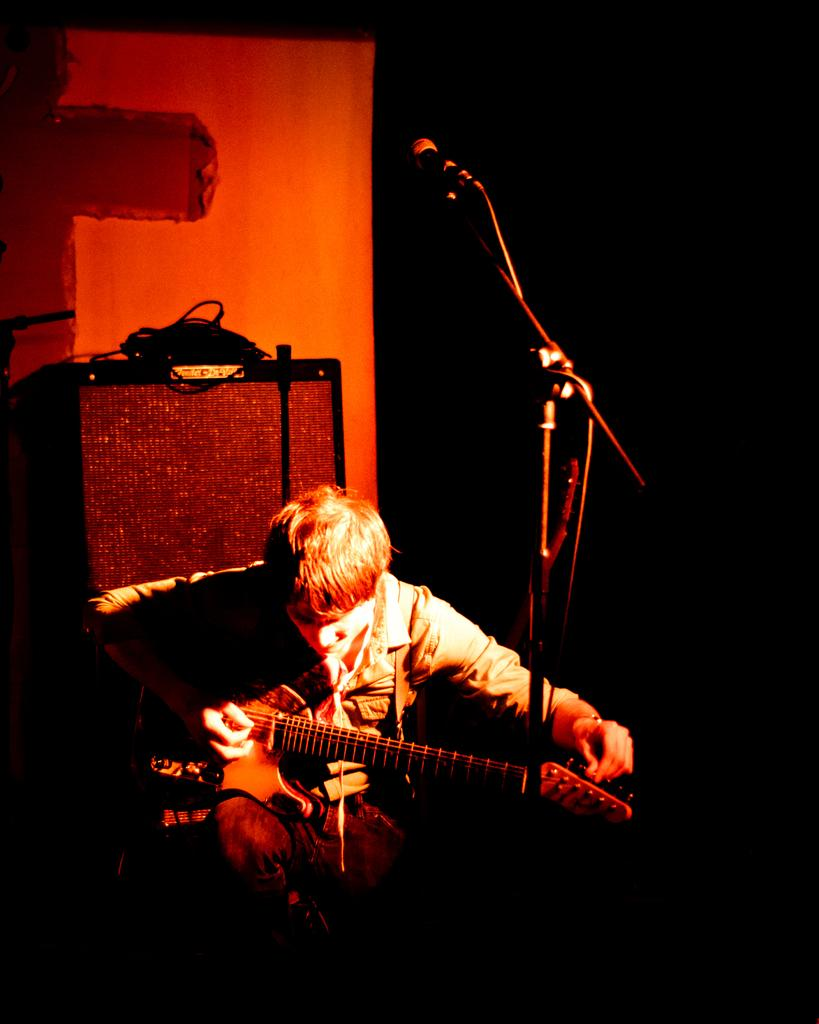What is the man in the image doing? The man is sitting and playing a guitar. What object is present in the image that is typically used for amplifying sound? There is a microphone in the image. What can be observed about the lighting in the image? The background of the image is dark. What additional object is present in the image, but its specific purpose is unclear? There is a device in the image, but its specific purpose is unclear. What type of animal is flying with wings in the image? There is no animal with wings present in the image. Can you describe the brain of the person in the image? The image does not show the man's brain, so it cannot be described. 